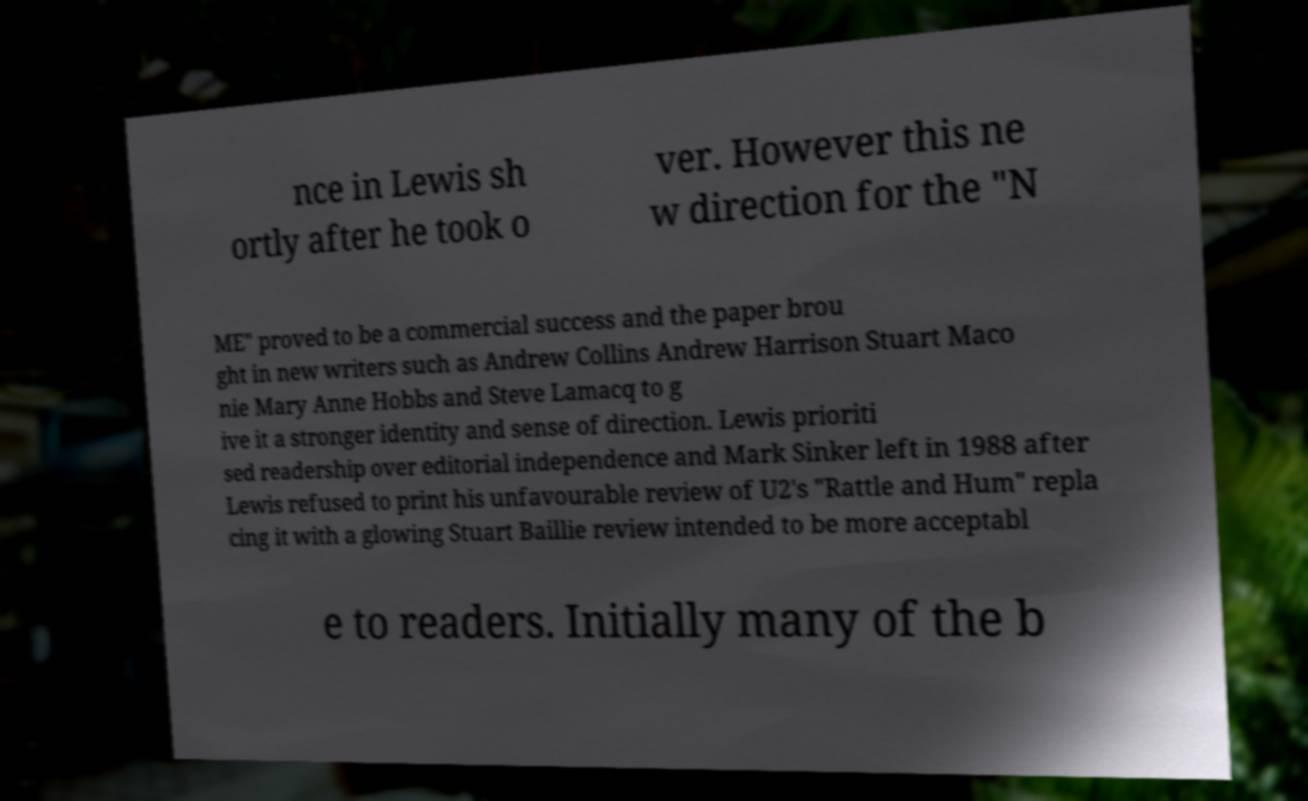There's text embedded in this image that I need extracted. Can you transcribe it verbatim? nce in Lewis sh ortly after he took o ver. However this ne w direction for the "N ME" proved to be a commercial success and the paper brou ght in new writers such as Andrew Collins Andrew Harrison Stuart Maco nie Mary Anne Hobbs and Steve Lamacq to g ive it a stronger identity and sense of direction. Lewis prioriti sed readership over editorial independence and Mark Sinker left in 1988 after Lewis refused to print his unfavourable review of U2's "Rattle and Hum" repla cing it with a glowing Stuart Baillie review intended to be more acceptabl e to readers. Initially many of the b 